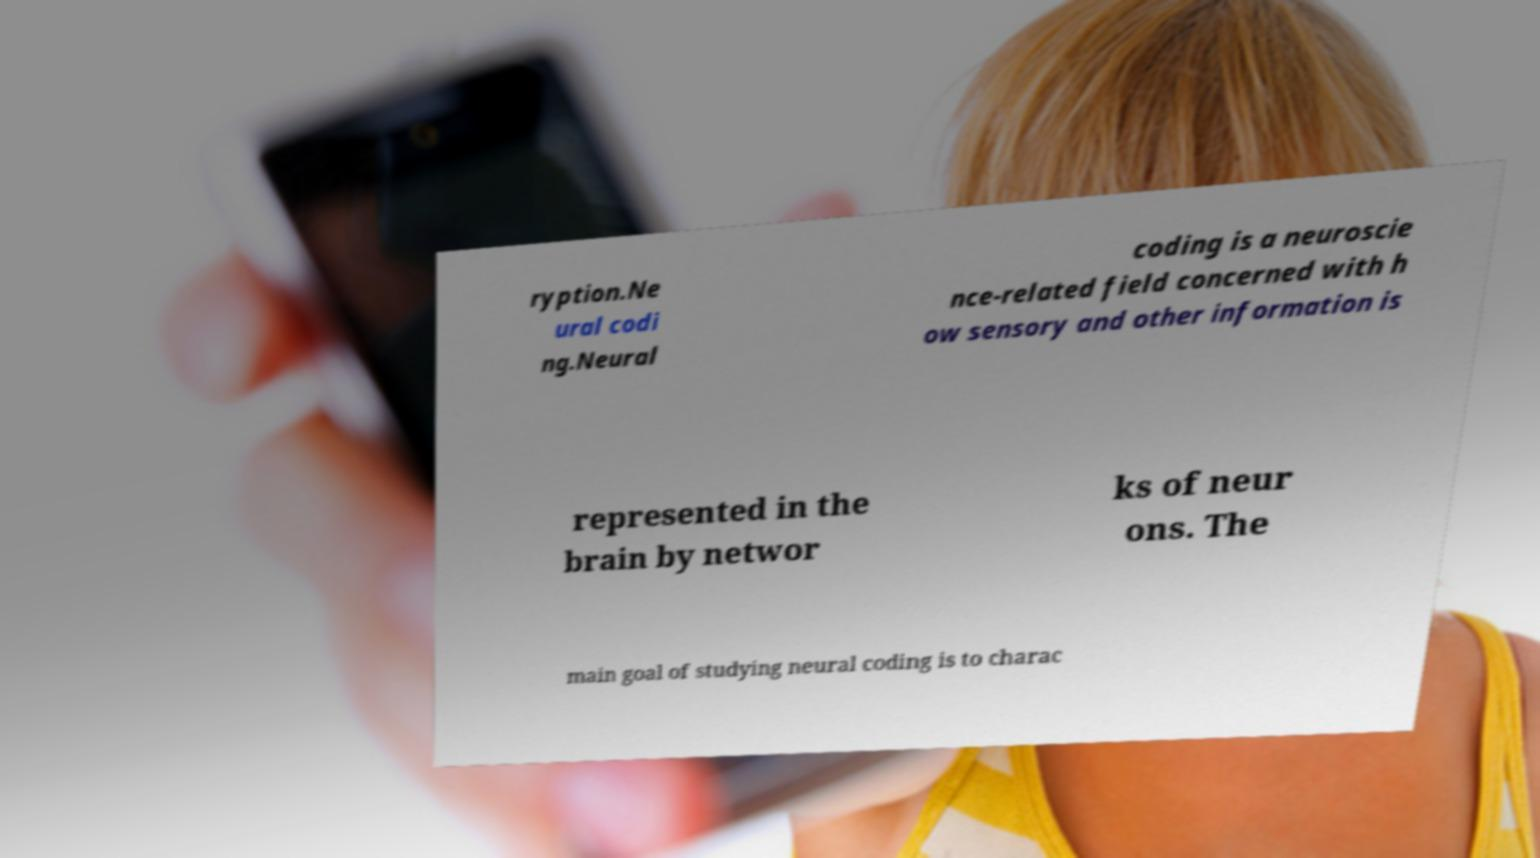Can you read and provide the text displayed in the image?This photo seems to have some interesting text. Can you extract and type it out for me? ryption.Ne ural codi ng.Neural coding is a neuroscie nce-related field concerned with h ow sensory and other information is represented in the brain by networ ks of neur ons. The main goal of studying neural coding is to charac 